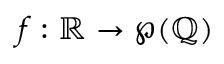<formula> <loc_0><loc_0><loc_500><loc_500>f \colon \mathbb { R } \to \wp ( \mathbb { Q } )</formula> 